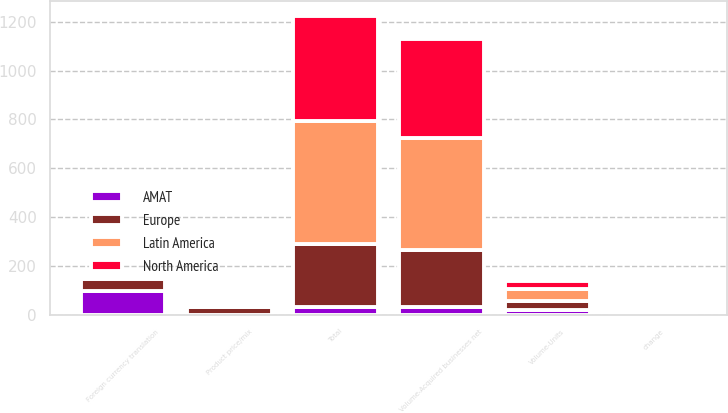Convert chart to OTSL. <chart><loc_0><loc_0><loc_500><loc_500><stacked_bar_chart><ecel><fcel>Volume-Units<fcel>change<fcel>Volume-Acquired businesses net<fcel>Product price/mix<fcel>Foreign currency translation<fcel>Total<nl><fcel>Latin America<fcel>48.2<fcel>1.9<fcel>455.3<fcel>0.8<fcel>1.2<fcel>503.1<nl><fcel>AMAT<fcel>21.1<fcel>1.3<fcel>33.3<fcel>0.3<fcel>97.7<fcel>33.3<nl><fcel>Europe<fcel>38.8<fcel>7.1<fcel>234.2<fcel>33.2<fcel>49.9<fcel>256.3<nl><fcel>North America<fcel>33.4<fcel>9.6<fcel>404.5<fcel>1.1<fcel>6<fcel>430.8<nl></chart> 